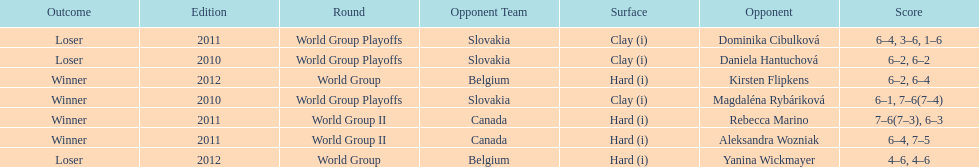Could you parse the entire table as a dict? {'header': ['Outcome', 'Edition', 'Round', 'Opponent Team', 'Surface', 'Opponent', 'Score'], 'rows': [['Loser', '2011', 'World Group Playoffs', 'Slovakia', 'Clay (i)', 'Dominika Cibulková', '6–4, 3–6, 1–6'], ['Loser', '2010', 'World Group Playoffs', 'Slovakia', 'Clay (i)', 'Daniela Hantuchová', '6–2, 6–2'], ['Winner', '2012', 'World Group', 'Belgium', 'Hard (i)', 'Kirsten Flipkens', '6–2, 6–4'], ['Winner', '2010', 'World Group Playoffs', 'Slovakia', 'Clay (i)', 'Magdaléna Rybáriková', '6–1, 7–6(7–4)'], ['Winner', '2011', 'World Group II', 'Canada', 'Hard (i)', 'Rebecca Marino', '7–6(7–3), 6–3'], ['Winner', '2011', 'World Group II', 'Canada', 'Hard (i)', 'Aleksandra Wozniak', '6–4, 7–5'], ['Loser', '2012', 'World Group', 'Belgium', 'Hard (i)', 'Yanina Wickmayer', '4–6, 4–6']]} What was the next game listed after the world group ii rounds? World Group Playoffs. 